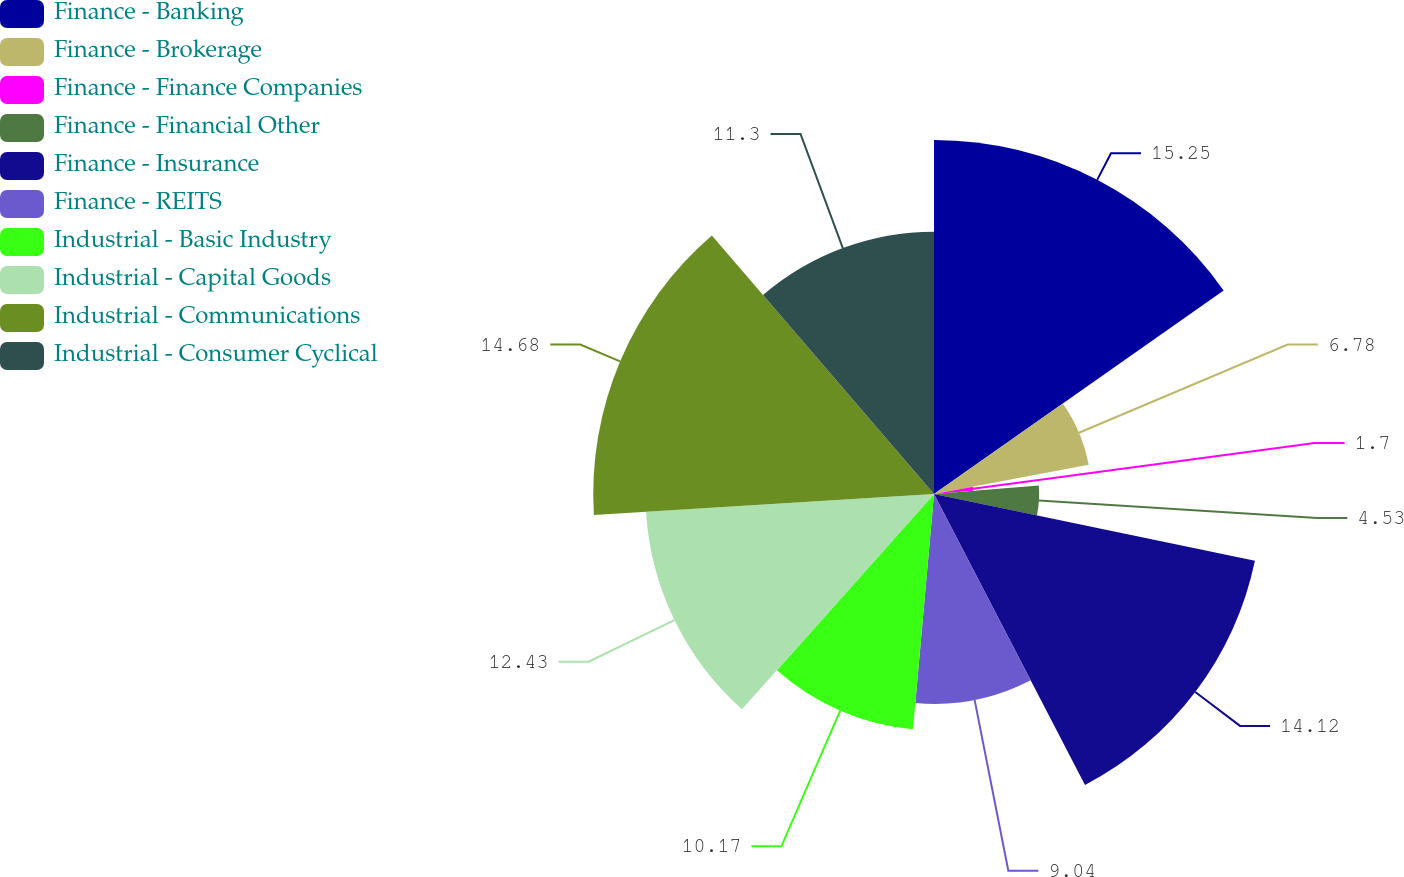Convert chart to OTSL. <chart><loc_0><loc_0><loc_500><loc_500><pie_chart><fcel>Finance - Banking<fcel>Finance - Brokerage<fcel>Finance - Finance Companies<fcel>Finance - Financial Other<fcel>Finance - Insurance<fcel>Finance - REITS<fcel>Industrial - Basic Industry<fcel>Industrial - Capital Goods<fcel>Industrial - Communications<fcel>Industrial - Consumer Cyclical<nl><fcel>15.25%<fcel>6.78%<fcel>1.7%<fcel>4.53%<fcel>14.12%<fcel>9.04%<fcel>10.17%<fcel>12.43%<fcel>14.68%<fcel>11.3%<nl></chart> 